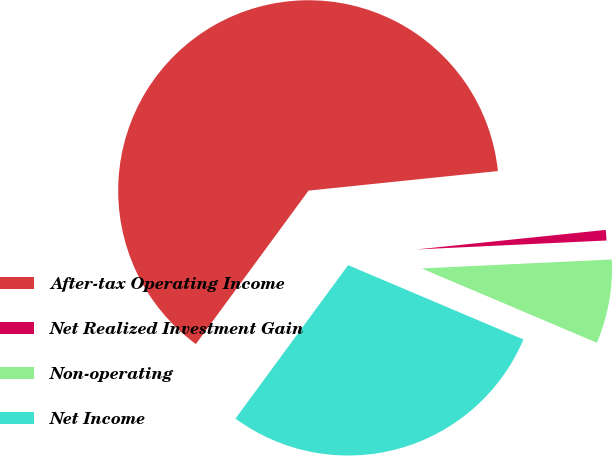Convert chart to OTSL. <chart><loc_0><loc_0><loc_500><loc_500><pie_chart><fcel>After-tax Operating Income<fcel>Net Realized Investment Gain<fcel>Non-operating<fcel>Net Income<nl><fcel>63.28%<fcel>0.89%<fcel>7.13%<fcel>28.7%<nl></chart> 